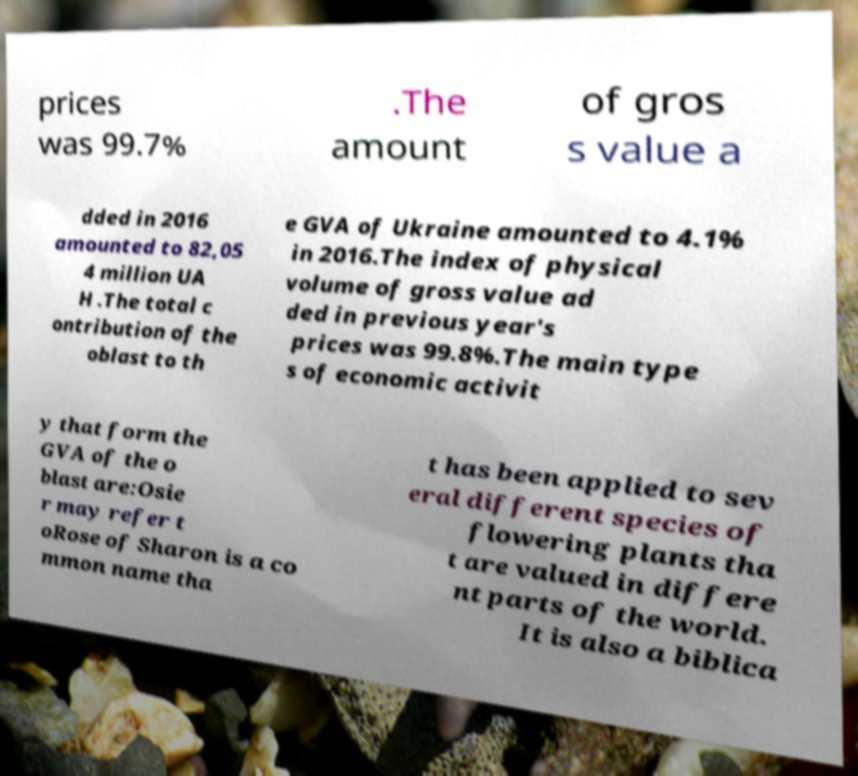Could you assist in decoding the text presented in this image and type it out clearly? prices was 99.7% .The amount of gros s value a dded in 2016 amounted to 82,05 4 million UA H .The total c ontribution of the oblast to th e GVA of Ukraine amounted to 4.1% in 2016.The index of physical volume of gross value ad ded in previous year's prices was 99.8%.The main type s of economic activit y that form the GVA of the o blast are:Osie r may refer t oRose of Sharon is a co mmon name tha t has been applied to sev eral different species of flowering plants tha t are valued in differe nt parts of the world. It is also a biblica 